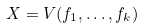Convert formula to latex. <formula><loc_0><loc_0><loc_500><loc_500>X = V ( f _ { 1 } , \dots , f _ { k } )</formula> 